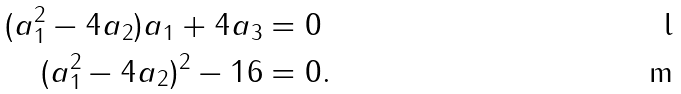Convert formula to latex. <formula><loc_0><loc_0><loc_500><loc_500>( a _ { 1 } ^ { 2 } - 4 a _ { 2 } ) a _ { 1 } + 4 a _ { 3 } & = 0 \\ ( a _ { 1 } ^ { 2 } - 4 a _ { 2 } ) ^ { 2 } - 1 6 & = 0 .</formula> 